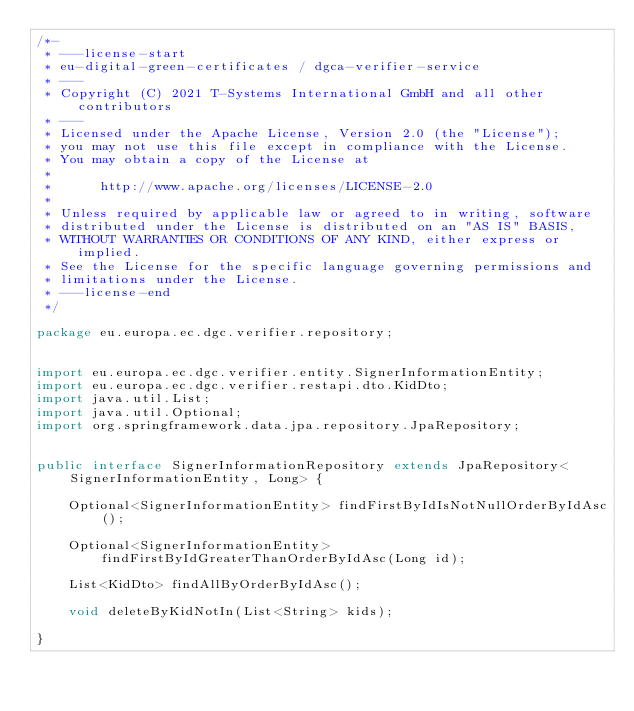Convert code to text. <code><loc_0><loc_0><loc_500><loc_500><_Java_>/*-
 * ---license-start
 * eu-digital-green-certificates / dgca-verifier-service
 * ---
 * Copyright (C) 2021 T-Systems International GmbH and all other contributors
 * ---
 * Licensed under the Apache License, Version 2.0 (the "License");
 * you may not use this file except in compliance with the License.
 * You may obtain a copy of the License at
 *
 *      http://www.apache.org/licenses/LICENSE-2.0
 *
 * Unless required by applicable law or agreed to in writing, software
 * distributed under the License is distributed on an "AS IS" BASIS,
 * WITHOUT WARRANTIES OR CONDITIONS OF ANY KIND, either express or implied.
 * See the License for the specific language governing permissions and
 * limitations under the License.
 * ---license-end
 */

package eu.europa.ec.dgc.verifier.repository;


import eu.europa.ec.dgc.verifier.entity.SignerInformationEntity;
import eu.europa.ec.dgc.verifier.restapi.dto.KidDto;
import java.util.List;
import java.util.Optional;
import org.springframework.data.jpa.repository.JpaRepository;


public interface SignerInformationRepository extends JpaRepository<SignerInformationEntity, Long> {

    Optional<SignerInformationEntity> findFirstByIdIsNotNullOrderByIdAsc();

    Optional<SignerInformationEntity> findFirstByIdGreaterThanOrderByIdAsc(Long id);

    List<KidDto> findAllByOrderByIdAsc();

    void deleteByKidNotIn(List<String> kids);

}
</code> 